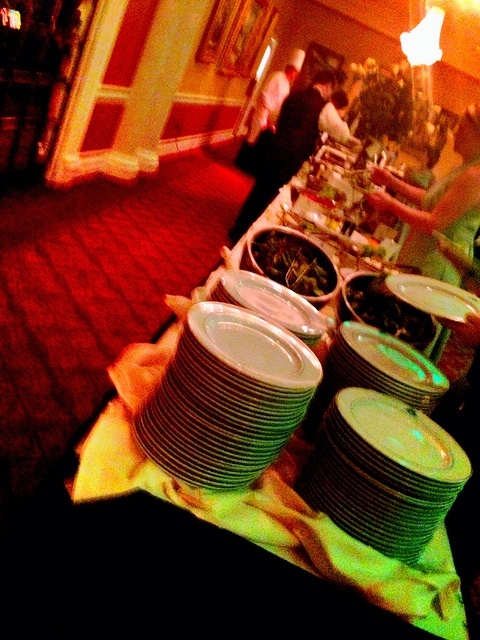Describe the objects in this image and their specific colors. I can see people in maroon, brown, and olive tones, people in maroon, black, and salmon tones, bowl in maroon, black, and brown tones, bowl in maroon, black, brown, and olive tones, and people in maroon, brown, red, and salmon tones in this image. 